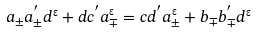Convert formula to latex. <formula><loc_0><loc_0><loc_500><loc_500>a _ { \pm } a _ { \pm } ^ { ^ { \prime } } d ^ { " } + d c ^ { ^ { \prime } } a _ { \mp } ^ { " } = c d ^ { ^ { \prime } } a ^ { " } _ { \pm } + b _ { \mp } b _ { \mp } ^ { ^ { \prime } } d ^ { " }</formula> 